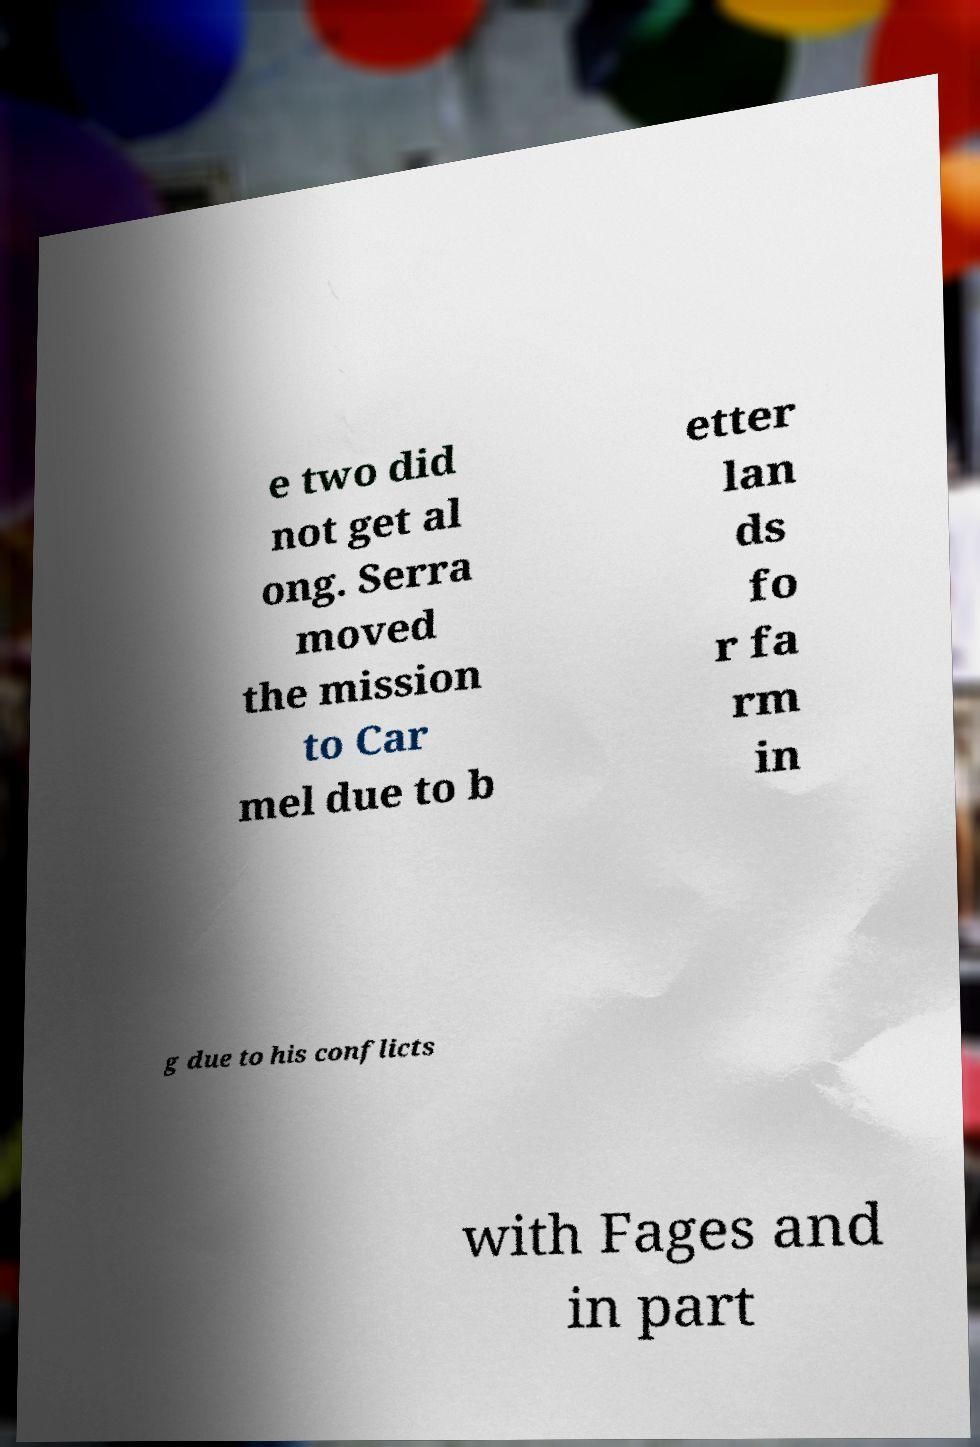Please read and relay the text visible in this image. What does it say? e two did not get al ong. Serra moved the mission to Car mel due to b etter lan ds fo r fa rm in g due to his conflicts with Fages and in part 